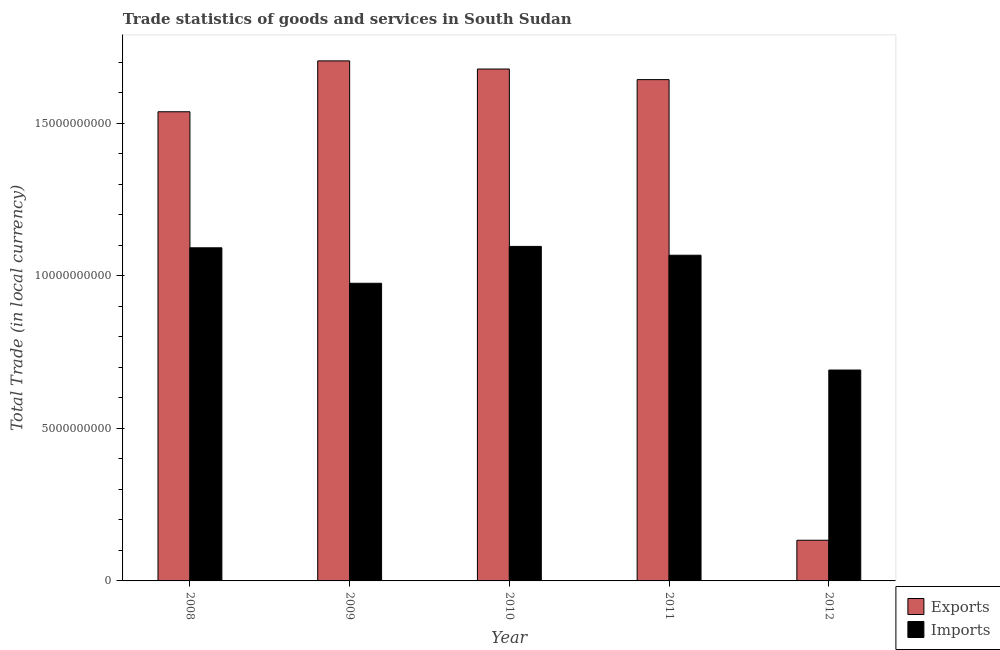Are the number of bars on each tick of the X-axis equal?
Your answer should be compact. Yes. How many bars are there on the 1st tick from the left?
Your response must be concise. 2. What is the label of the 2nd group of bars from the left?
Your response must be concise. 2009. In how many cases, is the number of bars for a given year not equal to the number of legend labels?
Give a very brief answer. 0. What is the export of goods and services in 2009?
Your answer should be very brief. 1.70e+1. Across all years, what is the maximum export of goods and services?
Keep it short and to the point. 1.70e+1. Across all years, what is the minimum imports of goods and services?
Your response must be concise. 6.91e+09. In which year was the export of goods and services maximum?
Provide a short and direct response. 2009. What is the total export of goods and services in the graph?
Your answer should be compact. 6.69e+1. What is the difference between the imports of goods and services in 2008 and that in 2009?
Give a very brief answer. 1.16e+09. What is the difference between the imports of goods and services in 2011 and the export of goods and services in 2008?
Offer a terse response. -2.43e+08. What is the average export of goods and services per year?
Provide a short and direct response. 1.34e+1. In the year 2010, what is the difference between the imports of goods and services and export of goods and services?
Offer a terse response. 0. In how many years, is the export of goods and services greater than 14000000000 LCU?
Make the answer very short. 4. What is the ratio of the export of goods and services in 2011 to that in 2012?
Give a very brief answer. 12.32. What is the difference between the highest and the second highest imports of goods and services?
Offer a terse response. 4.60e+07. What is the difference between the highest and the lowest export of goods and services?
Offer a very short reply. 1.57e+1. What does the 1st bar from the left in 2010 represents?
Your response must be concise. Exports. What does the 2nd bar from the right in 2010 represents?
Make the answer very short. Exports. How many bars are there?
Offer a very short reply. 10. Are the values on the major ticks of Y-axis written in scientific E-notation?
Make the answer very short. No. Does the graph contain grids?
Offer a terse response. No. How many legend labels are there?
Give a very brief answer. 2. How are the legend labels stacked?
Offer a terse response. Vertical. What is the title of the graph?
Offer a terse response. Trade statistics of goods and services in South Sudan. Does "Depositors" appear as one of the legend labels in the graph?
Provide a succinct answer. No. What is the label or title of the Y-axis?
Provide a short and direct response. Total Trade (in local currency). What is the Total Trade (in local currency) in Exports in 2008?
Make the answer very short. 1.54e+1. What is the Total Trade (in local currency) in Imports in 2008?
Offer a terse response. 1.09e+1. What is the Total Trade (in local currency) of Exports in 2009?
Your answer should be compact. 1.70e+1. What is the Total Trade (in local currency) of Imports in 2009?
Ensure brevity in your answer.  9.75e+09. What is the Total Trade (in local currency) in Exports in 2010?
Provide a short and direct response. 1.68e+1. What is the Total Trade (in local currency) of Imports in 2010?
Your response must be concise. 1.10e+1. What is the Total Trade (in local currency) of Exports in 2011?
Provide a succinct answer. 1.64e+1. What is the Total Trade (in local currency) in Imports in 2011?
Your answer should be very brief. 1.07e+1. What is the Total Trade (in local currency) of Exports in 2012?
Offer a terse response. 1.33e+09. What is the Total Trade (in local currency) of Imports in 2012?
Provide a short and direct response. 6.91e+09. Across all years, what is the maximum Total Trade (in local currency) in Exports?
Provide a succinct answer. 1.70e+1. Across all years, what is the maximum Total Trade (in local currency) in Imports?
Ensure brevity in your answer.  1.10e+1. Across all years, what is the minimum Total Trade (in local currency) of Exports?
Ensure brevity in your answer.  1.33e+09. Across all years, what is the minimum Total Trade (in local currency) in Imports?
Your response must be concise. 6.91e+09. What is the total Total Trade (in local currency) of Exports in the graph?
Offer a terse response. 6.69e+1. What is the total Total Trade (in local currency) in Imports in the graph?
Your answer should be compact. 4.92e+1. What is the difference between the Total Trade (in local currency) of Exports in 2008 and that in 2009?
Provide a succinct answer. -1.67e+09. What is the difference between the Total Trade (in local currency) of Imports in 2008 and that in 2009?
Make the answer very short. 1.16e+09. What is the difference between the Total Trade (in local currency) of Exports in 2008 and that in 2010?
Keep it short and to the point. -1.40e+09. What is the difference between the Total Trade (in local currency) in Imports in 2008 and that in 2010?
Your answer should be very brief. -4.60e+07. What is the difference between the Total Trade (in local currency) in Exports in 2008 and that in 2011?
Give a very brief answer. -1.05e+09. What is the difference between the Total Trade (in local currency) in Imports in 2008 and that in 2011?
Offer a very short reply. 2.43e+08. What is the difference between the Total Trade (in local currency) of Exports in 2008 and that in 2012?
Offer a terse response. 1.40e+1. What is the difference between the Total Trade (in local currency) of Imports in 2008 and that in 2012?
Keep it short and to the point. 4.00e+09. What is the difference between the Total Trade (in local currency) in Exports in 2009 and that in 2010?
Provide a short and direct response. 2.67e+08. What is the difference between the Total Trade (in local currency) of Imports in 2009 and that in 2010?
Provide a short and direct response. -1.21e+09. What is the difference between the Total Trade (in local currency) of Exports in 2009 and that in 2011?
Provide a succinct answer. 6.14e+08. What is the difference between the Total Trade (in local currency) in Imports in 2009 and that in 2011?
Give a very brief answer. -9.19e+08. What is the difference between the Total Trade (in local currency) of Exports in 2009 and that in 2012?
Offer a terse response. 1.57e+1. What is the difference between the Total Trade (in local currency) in Imports in 2009 and that in 2012?
Make the answer very short. 2.84e+09. What is the difference between the Total Trade (in local currency) in Exports in 2010 and that in 2011?
Keep it short and to the point. 3.47e+08. What is the difference between the Total Trade (in local currency) in Imports in 2010 and that in 2011?
Provide a short and direct response. 2.89e+08. What is the difference between the Total Trade (in local currency) of Exports in 2010 and that in 2012?
Your response must be concise. 1.54e+1. What is the difference between the Total Trade (in local currency) in Imports in 2010 and that in 2012?
Provide a succinct answer. 4.05e+09. What is the difference between the Total Trade (in local currency) in Exports in 2011 and that in 2012?
Offer a terse response. 1.51e+1. What is the difference between the Total Trade (in local currency) in Imports in 2011 and that in 2012?
Make the answer very short. 3.76e+09. What is the difference between the Total Trade (in local currency) in Exports in 2008 and the Total Trade (in local currency) in Imports in 2009?
Provide a short and direct response. 5.62e+09. What is the difference between the Total Trade (in local currency) in Exports in 2008 and the Total Trade (in local currency) in Imports in 2010?
Make the answer very short. 4.41e+09. What is the difference between the Total Trade (in local currency) in Exports in 2008 and the Total Trade (in local currency) in Imports in 2011?
Make the answer very short. 4.70e+09. What is the difference between the Total Trade (in local currency) in Exports in 2008 and the Total Trade (in local currency) in Imports in 2012?
Keep it short and to the point. 8.46e+09. What is the difference between the Total Trade (in local currency) of Exports in 2009 and the Total Trade (in local currency) of Imports in 2010?
Offer a very short reply. 6.08e+09. What is the difference between the Total Trade (in local currency) in Exports in 2009 and the Total Trade (in local currency) in Imports in 2011?
Give a very brief answer. 6.37e+09. What is the difference between the Total Trade (in local currency) in Exports in 2009 and the Total Trade (in local currency) in Imports in 2012?
Offer a very short reply. 1.01e+1. What is the difference between the Total Trade (in local currency) in Exports in 2010 and the Total Trade (in local currency) in Imports in 2011?
Your answer should be compact. 6.10e+09. What is the difference between the Total Trade (in local currency) in Exports in 2010 and the Total Trade (in local currency) in Imports in 2012?
Your answer should be compact. 9.86e+09. What is the difference between the Total Trade (in local currency) in Exports in 2011 and the Total Trade (in local currency) in Imports in 2012?
Keep it short and to the point. 9.52e+09. What is the average Total Trade (in local currency) of Exports per year?
Provide a short and direct response. 1.34e+1. What is the average Total Trade (in local currency) in Imports per year?
Provide a succinct answer. 9.84e+09. In the year 2008, what is the difference between the Total Trade (in local currency) in Exports and Total Trade (in local currency) in Imports?
Ensure brevity in your answer.  4.46e+09. In the year 2009, what is the difference between the Total Trade (in local currency) of Exports and Total Trade (in local currency) of Imports?
Give a very brief answer. 7.29e+09. In the year 2010, what is the difference between the Total Trade (in local currency) of Exports and Total Trade (in local currency) of Imports?
Offer a terse response. 5.81e+09. In the year 2011, what is the difference between the Total Trade (in local currency) in Exports and Total Trade (in local currency) in Imports?
Provide a succinct answer. 5.75e+09. In the year 2012, what is the difference between the Total Trade (in local currency) of Exports and Total Trade (in local currency) of Imports?
Offer a very short reply. -5.58e+09. What is the ratio of the Total Trade (in local currency) of Exports in 2008 to that in 2009?
Give a very brief answer. 0.9. What is the ratio of the Total Trade (in local currency) of Imports in 2008 to that in 2009?
Keep it short and to the point. 1.12. What is the ratio of the Total Trade (in local currency) in Exports in 2008 to that in 2010?
Provide a succinct answer. 0.92. What is the ratio of the Total Trade (in local currency) of Exports in 2008 to that in 2011?
Ensure brevity in your answer.  0.94. What is the ratio of the Total Trade (in local currency) in Imports in 2008 to that in 2011?
Make the answer very short. 1.02. What is the ratio of the Total Trade (in local currency) of Exports in 2008 to that in 2012?
Provide a short and direct response. 11.53. What is the ratio of the Total Trade (in local currency) in Imports in 2008 to that in 2012?
Your answer should be very brief. 1.58. What is the ratio of the Total Trade (in local currency) of Exports in 2009 to that in 2010?
Offer a very short reply. 1.02. What is the ratio of the Total Trade (in local currency) in Imports in 2009 to that in 2010?
Provide a succinct answer. 0.89. What is the ratio of the Total Trade (in local currency) of Exports in 2009 to that in 2011?
Your response must be concise. 1.04. What is the ratio of the Total Trade (in local currency) of Imports in 2009 to that in 2011?
Give a very brief answer. 0.91. What is the ratio of the Total Trade (in local currency) in Exports in 2009 to that in 2012?
Give a very brief answer. 12.78. What is the ratio of the Total Trade (in local currency) in Imports in 2009 to that in 2012?
Make the answer very short. 1.41. What is the ratio of the Total Trade (in local currency) in Exports in 2010 to that in 2011?
Offer a terse response. 1.02. What is the ratio of the Total Trade (in local currency) of Imports in 2010 to that in 2011?
Your answer should be very brief. 1.03. What is the ratio of the Total Trade (in local currency) in Exports in 2010 to that in 2012?
Offer a very short reply. 12.58. What is the ratio of the Total Trade (in local currency) in Imports in 2010 to that in 2012?
Provide a short and direct response. 1.59. What is the ratio of the Total Trade (in local currency) of Exports in 2011 to that in 2012?
Give a very brief answer. 12.32. What is the ratio of the Total Trade (in local currency) of Imports in 2011 to that in 2012?
Ensure brevity in your answer.  1.54. What is the difference between the highest and the second highest Total Trade (in local currency) of Exports?
Your response must be concise. 2.67e+08. What is the difference between the highest and the second highest Total Trade (in local currency) of Imports?
Provide a short and direct response. 4.60e+07. What is the difference between the highest and the lowest Total Trade (in local currency) of Exports?
Your answer should be very brief. 1.57e+1. What is the difference between the highest and the lowest Total Trade (in local currency) of Imports?
Make the answer very short. 4.05e+09. 